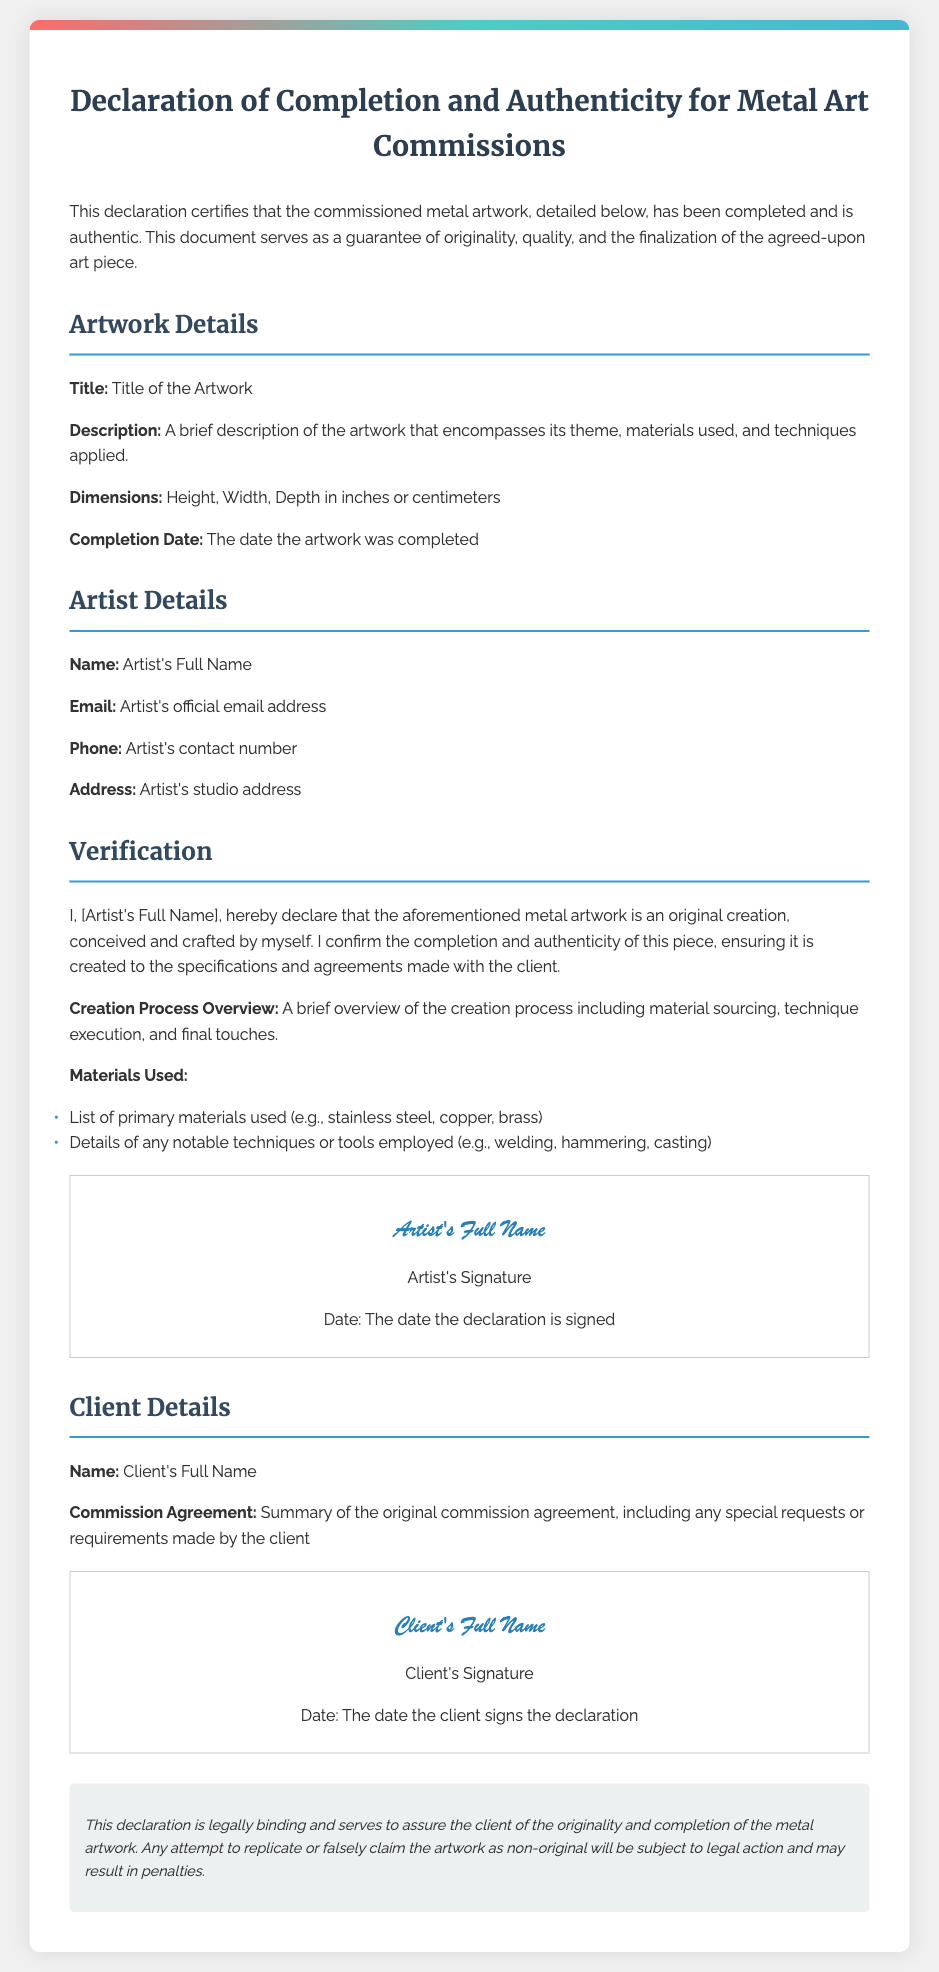what is the title of the artwork? The title of the artwork is specified in the details section under "Title."
Answer: Title of the Artwork what is the completion date of the artwork? The completion date can be found in the details section under "Completion Date."
Answer: The date the artwork was completed who is the artist? The artist's full name is required in the "Artist Details" section.
Answer: Artist's Full Name what materials are listed in the materials used section? The materials used are listed in the "Materials Used" section, where primary materials and techniques are mentioned.
Answer: List of primary materials used (e.g., stainless steel, copper, brass) what is the purpose of this declaration? The purpose of the declaration is stated at the beginning, as a guarantee of originality and completion of the artwork.
Answer: Guarantee of originality, quality, and the finalization of the agreed-upon art piece who is the client? The client's full name is found in the "Client Details" section of the document.
Answer: Client's Full Name when is the declaration legally binding? The declaration is considered legally binding as mentioned in the legal note section.
Answer: Legally binding how is the originality of the artwork confirmed? The originality is confirmed through the artist's declaration in the verification section.
Answer: Declaration by the artist what should the client do if they find the artwork is not original? If the artwork is found to be non-original, the legal note indicates that legal action may be taken.
Answer: Legal action may be taken 